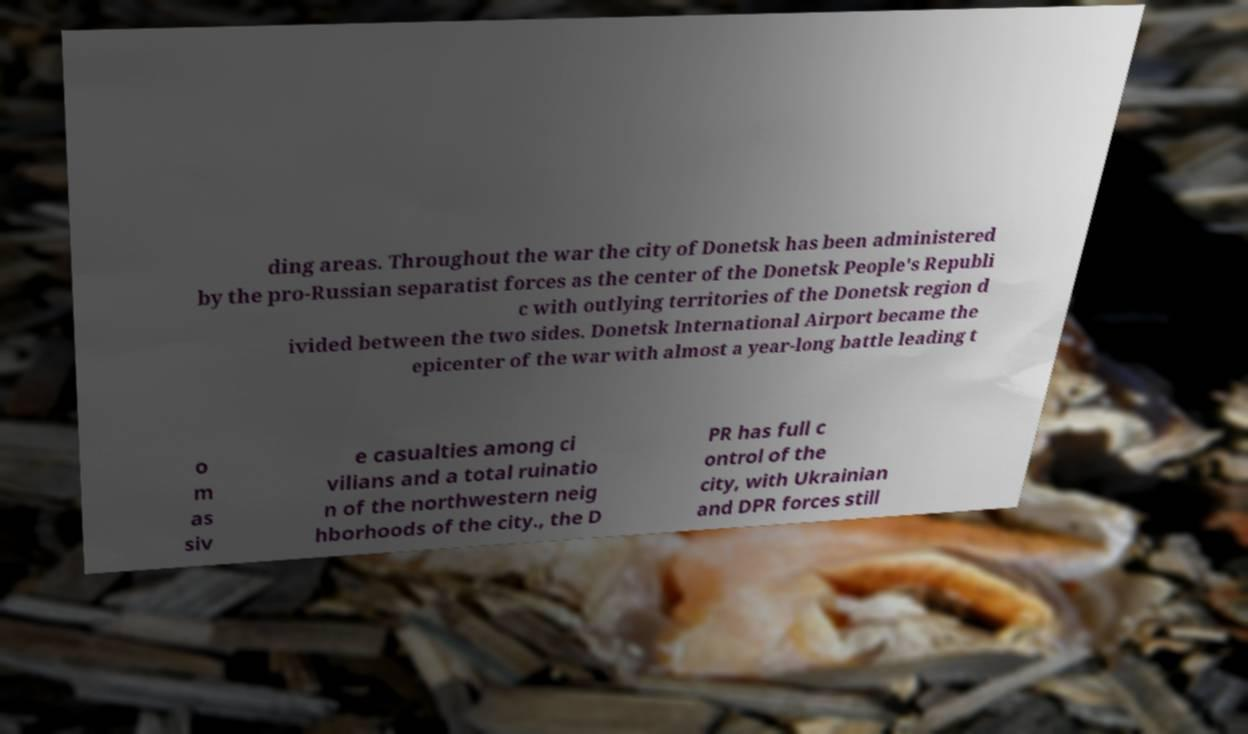Can you read and provide the text displayed in the image?This photo seems to have some interesting text. Can you extract and type it out for me? ding areas. Throughout the war the city of Donetsk has been administered by the pro-Russian separatist forces as the center of the Donetsk People's Republi c with outlying territories of the Donetsk region d ivided between the two sides. Donetsk International Airport became the epicenter of the war with almost a year-long battle leading t o m as siv e casualties among ci vilians and a total ruinatio n of the northwestern neig hborhoods of the city., the D PR has full c ontrol of the city, with Ukrainian and DPR forces still 